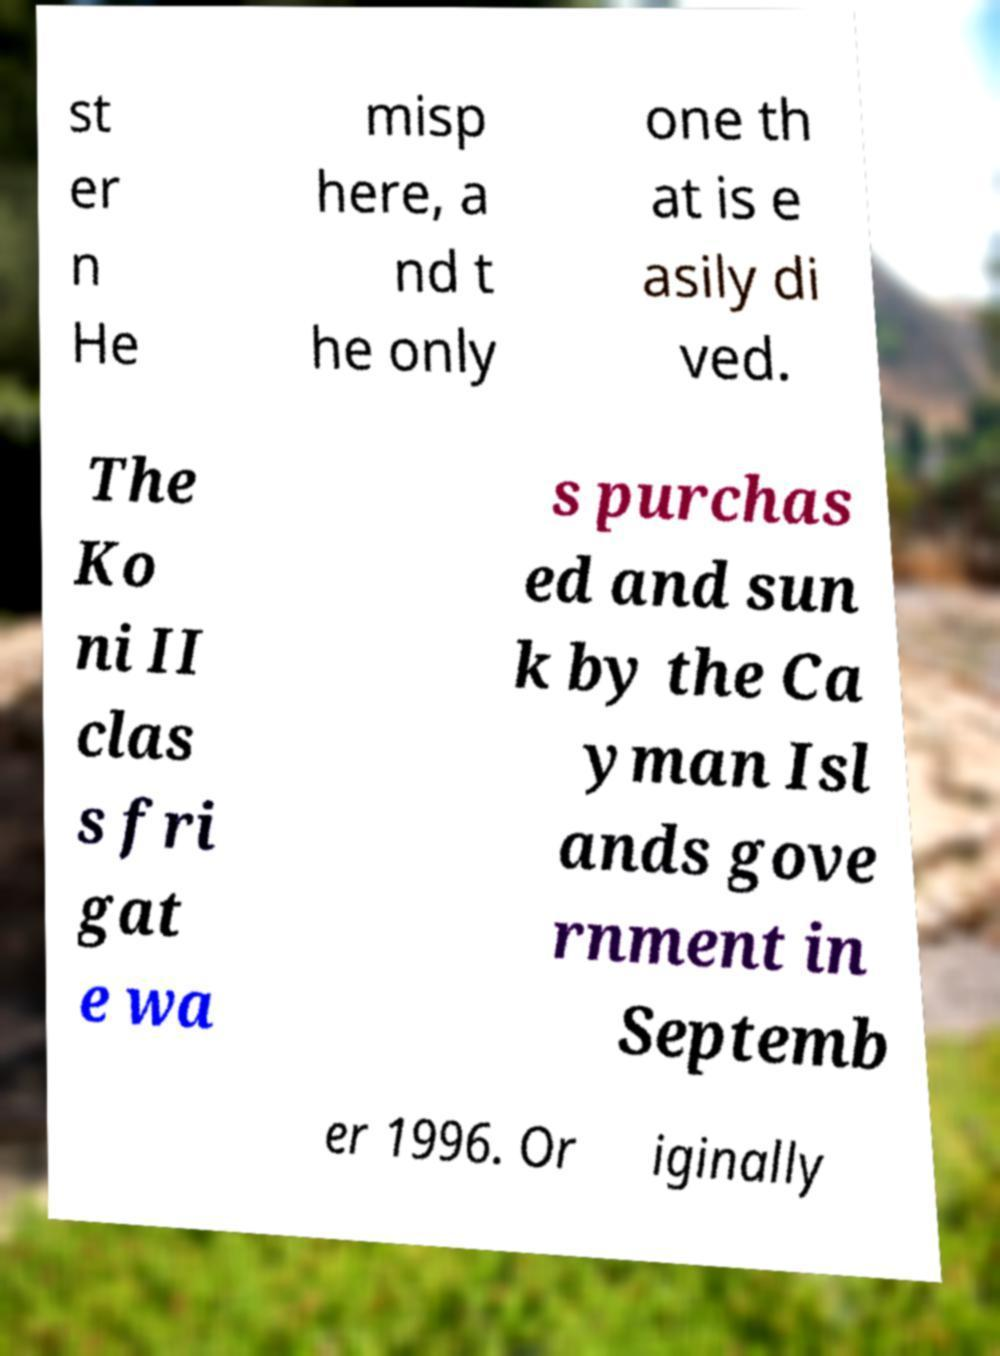Please read and relay the text visible in this image. What does it say? st er n He misp here, a nd t he only one th at is e asily di ved. The Ko ni II clas s fri gat e wa s purchas ed and sun k by the Ca yman Isl ands gove rnment in Septemb er 1996. Or iginally 